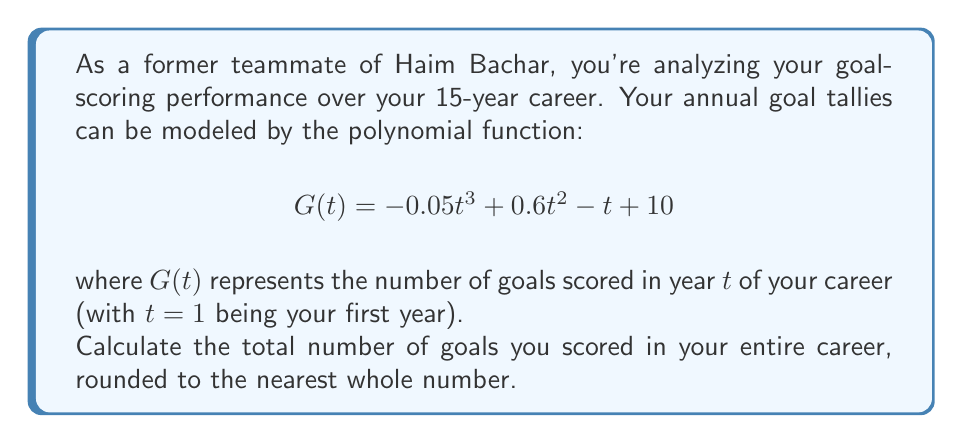Give your solution to this math problem. To solve this problem, we need to follow these steps:

1) The function $G(t)$ gives us the number of goals scored in each year. To find the total number of goals over the 15-year career, we need to sum $G(t)$ for $t$ from 1 to 15.

2) This sum can be represented as:

   $$\sum_{t=1}^{15} G(t) = \sum_{t=1}^{15} (-0.05t^3 + 0.6t^2 - t + 10)$$

3) While we could calculate this sum manually, it's more efficient to use the formulas for the sum of powers:

   $$\sum_{t=1}^{n} t = \frac{n(n+1)}{2}$$
   $$\sum_{t=1}^{n} t^2 = \frac{n(n+1)(2n+1)}{6}$$
   $$\sum_{t=1}^{n} t^3 = \left(\frac{n(n+1)}{2}\right)^2$$

4) Applying these formulas with $n=15$:

   $$-0.05 \sum_{t=1}^{15} t^3 + 0.6 \sum_{t=1}^{15} t^2 - \sum_{t=1}^{15} t + 10 \sum_{t=1}^{15} 1$$

5) Substituting the values:

   $$-0.05 \left(\frac{15(16)}{2}\right)^2 + 0.6 \frac{15(16)(31)}{6} - \frac{15(16)}{2} + 10(15)$$

6) Simplifying:

   $$-0.05(14400) + 0.6(1240) - 120 + 150$$
   $$= -720 + 744 - 120 + 150$$
   $$= 54$$

Therefore, the total number of goals scored over the 15-year career is 54.
Answer: 54 goals 